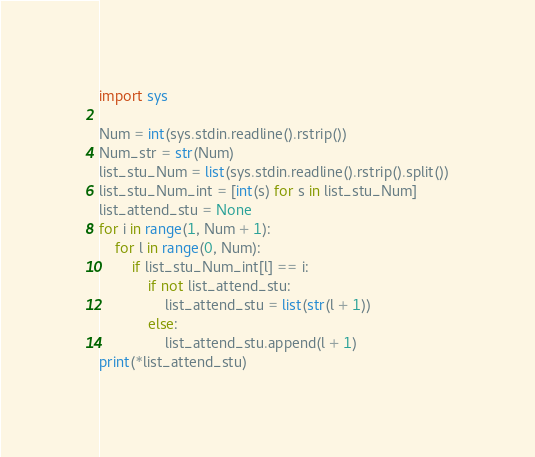<code> <loc_0><loc_0><loc_500><loc_500><_Python_>import sys

Num = int(sys.stdin.readline().rstrip())
Num_str = str(Num)
list_stu_Num = list(sys.stdin.readline().rstrip().split())
list_stu_Num_int = [int(s) for s in list_stu_Num]
list_attend_stu = None
for i in range(1, Num + 1):
    for l in range(0, Num):
        if list_stu_Num_int[l] == i:
            if not list_attend_stu:
                list_attend_stu = list(str(l + 1))
            else:
                list_attend_stu.append(l + 1)
print(*list_attend_stu)
</code> 